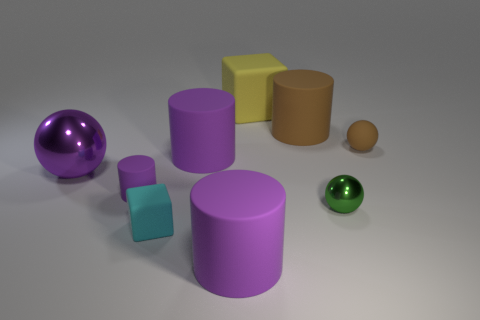Subtract all gray cubes. How many purple cylinders are left? 3 Add 1 small shiny balls. How many objects exist? 10 Subtract all cylinders. How many objects are left? 5 Add 6 large cubes. How many large cubes exist? 7 Subtract 1 purple spheres. How many objects are left? 8 Subtract all brown matte things. Subtract all tiny brown spheres. How many objects are left? 6 Add 4 matte cubes. How many matte cubes are left? 6 